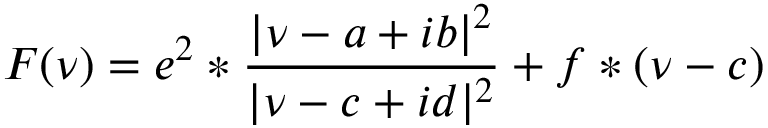Convert formula to latex. <formula><loc_0><loc_0><loc_500><loc_500>F ( \nu ) = e ^ { 2 } * \frac { | \nu - a + i b | ^ { 2 } } { | \nu - c + i d | ^ { 2 } } + f * ( \nu - c )</formula> 